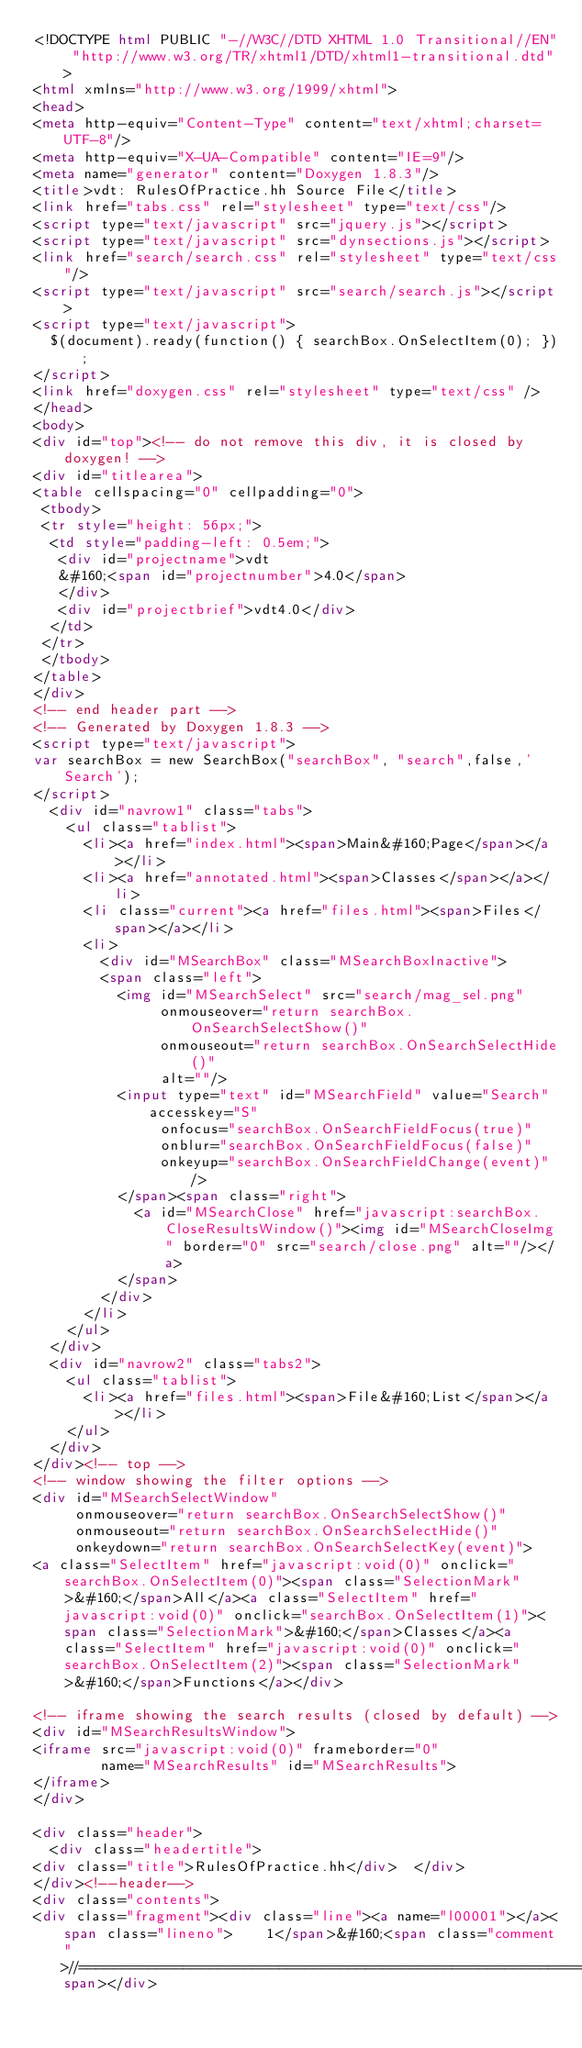Convert code to text. <code><loc_0><loc_0><loc_500><loc_500><_HTML_><!DOCTYPE html PUBLIC "-//W3C//DTD XHTML 1.0 Transitional//EN" "http://www.w3.org/TR/xhtml1/DTD/xhtml1-transitional.dtd">
<html xmlns="http://www.w3.org/1999/xhtml">
<head>
<meta http-equiv="Content-Type" content="text/xhtml;charset=UTF-8"/>
<meta http-equiv="X-UA-Compatible" content="IE=9"/>
<meta name="generator" content="Doxygen 1.8.3"/>
<title>vdt: RulesOfPractice.hh Source File</title>
<link href="tabs.css" rel="stylesheet" type="text/css"/>
<script type="text/javascript" src="jquery.js"></script>
<script type="text/javascript" src="dynsections.js"></script>
<link href="search/search.css" rel="stylesheet" type="text/css"/>
<script type="text/javascript" src="search/search.js"></script>
<script type="text/javascript">
  $(document).ready(function() { searchBox.OnSelectItem(0); });
</script>
<link href="doxygen.css" rel="stylesheet" type="text/css" />
</head>
<body>
<div id="top"><!-- do not remove this div, it is closed by doxygen! -->
<div id="titlearea">
<table cellspacing="0" cellpadding="0">
 <tbody>
 <tr style="height: 56px;">
  <td style="padding-left: 0.5em;">
   <div id="projectname">vdt
   &#160;<span id="projectnumber">4.0</span>
   </div>
   <div id="projectbrief">vdt4.0</div>
  </td>
 </tr>
 </tbody>
</table>
</div>
<!-- end header part -->
<!-- Generated by Doxygen 1.8.3 -->
<script type="text/javascript">
var searchBox = new SearchBox("searchBox", "search",false,'Search');
</script>
  <div id="navrow1" class="tabs">
    <ul class="tablist">
      <li><a href="index.html"><span>Main&#160;Page</span></a></li>
      <li><a href="annotated.html"><span>Classes</span></a></li>
      <li class="current"><a href="files.html"><span>Files</span></a></li>
      <li>
        <div id="MSearchBox" class="MSearchBoxInactive">
        <span class="left">
          <img id="MSearchSelect" src="search/mag_sel.png"
               onmouseover="return searchBox.OnSearchSelectShow()"
               onmouseout="return searchBox.OnSearchSelectHide()"
               alt=""/>
          <input type="text" id="MSearchField" value="Search" accesskey="S"
               onfocus="searchBox.OnSearchFieldFocus(true)" 
               onblur="searchBox.OnSearchFieldFocus(false)" 
               onkeyup="searchBox.OnSearchFieldChange(event)"/>
          </span><span class="right">
            <a id="MSearchClose" href="javascript:searchBox.CloseResultsWindow()"><img id="MSearchCloseImg" border="0" src="search/close.png" alt=""/></a>
          </span>
        </div>
      </li>
    </ul>
  </div>
  <div id="navrow2" class="tabs2">
    <ul class="tablist">
      <li><a href="files.html"><span>File&#160;List</span></a></li>
    </ul>
  </div>
</div><!-- top -->
<!-- window showing the filter options -->
<div id="MSearchSelectWindow"
     onmouseover="return searchBox.OnSearchSelectShow()"
     onmouseout="return searchBox.OnSearchSelectHide()"
     onkeydown="return searchBox.OnSearchSelectKey(event)">
<a class="SelectItem" href="javascript:void(0)" onclick="searchBox.OnSelectItem(0)"><span class="SelectionMark">&#160;</span>All</a><a class="SelectItem" href="javascript:void(0)" onclick="searchBox.OnSelectItem(1)"><span class="SelectionMark">&#160;</span>Classes</a><a class="SelectItem" href="javascript:void(0)" onclick="searchBox.OnSelectItem(2)"><span class="SelectionMark">&#160;</span>Functions</a></div>

<!-- iframe showing the search results (closed by default) -->
<div id="MSearchResultsWindow">
<iframe src="javascript:void(0)" frameborder="0" 
        name="MSearchResults" id="MSearchResults">
</iframe>
</div>

<div class="header">
  <div class="headertitle">
<div class="title">RulesOfPractice.hh</div>  </div>
</div><!--header-->
<div class="contents">
<div class="fragment"><div class="line"><a name="l00001"></a><span class="lineno">    1</span>&#160;<span class="comment">//=======================================================================</span></div></code> 